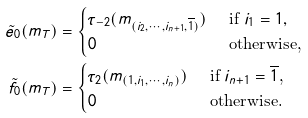Convert formula to latex. <formula><loc_0><loc_0><loc_500><loc_500>\tilde { e } _ { 0 } ( m _ { T } ) & = \begin{cases} \tau _ { - 2 } ( m _ { ( i _ { 2 } , \cdots , i _ { n + 1 } , \overline { 1 } ) } ) & \text { if $i_{1} = 1$} , \\ 0 & \text { otherwise,} \end{cases} \\ \tilde { f } _ { 0 } ( m _ { T } ) & = \begin{cases} \tau _ { 2 } ( m _ { ( 1 , i _ { 1 } , \cdots , i _ { n } ) } ) & \text { if $i_{n+1}=\overline{1}$,} \\ 0 & \text { otherwise.} \end{cases}</formula> 